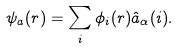<formula> <loc_0><loc_0><loc_500><loc_500>\psi _ { a } ( { r } ) = \sum _ { i } \phi _ { i } ( { r } ) { \hat { a } } _ { \alpha } ( { i } ) .</formula> 